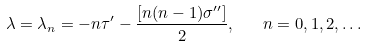Convert formula to latex. <formula><loc_0><loc_0><loc_500><loc_500>\lambda = \lambda _ { n } = - n \tau ^ { \prime } - \frac { \left [ n ( n - 1 ) \sigma ^ { \prime \prime } \right ] } { 2 } , \quad n = 0 , 1 , 2 , \dots</formula> 